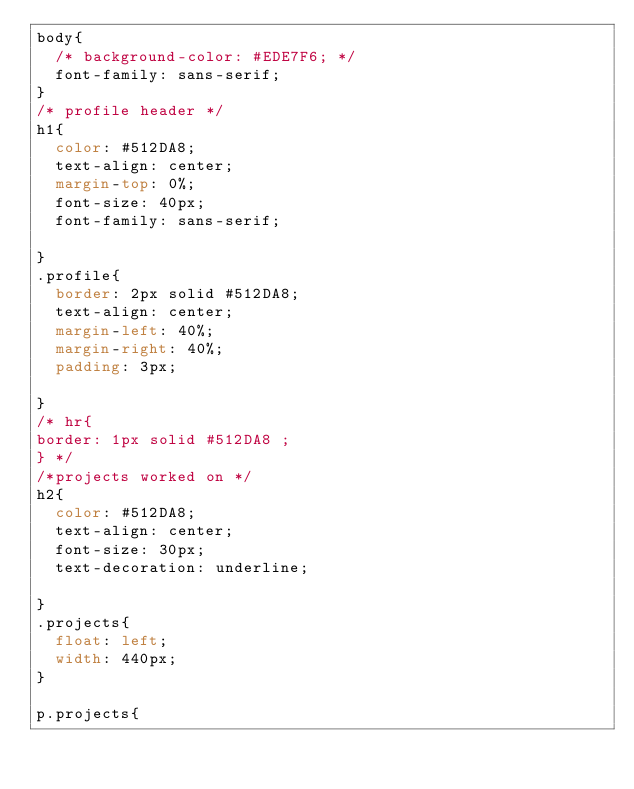Convert code to text. <code><loc_0><loc_0><loc_500><loc_500><_CSS_>body{
  /* background-color: #EDE7F6; */
  font-family: sans-serif;
}
/* profile header */
h1{
  color: #512DA8;
  text-align: center;
  margin-top: 0%;
  font-size: 40px;
  font-family: sans-serif;

}
.profile{
  border: 2px solid #512DA8;
  text-align: center;
  margin-left: 40%;
  margin-right: 40%;
  padding: 3px;

}
/* hr{
border: 1px solid #512DA8 ;
} */
/*projects worked on */
h2{
  color: #512DA8;
  text-align: center;
  font-size: 30px;
  text-decoration: underline;

}
.projects{
  float: left;
  width: 440px;
}

p.projects{</code> 